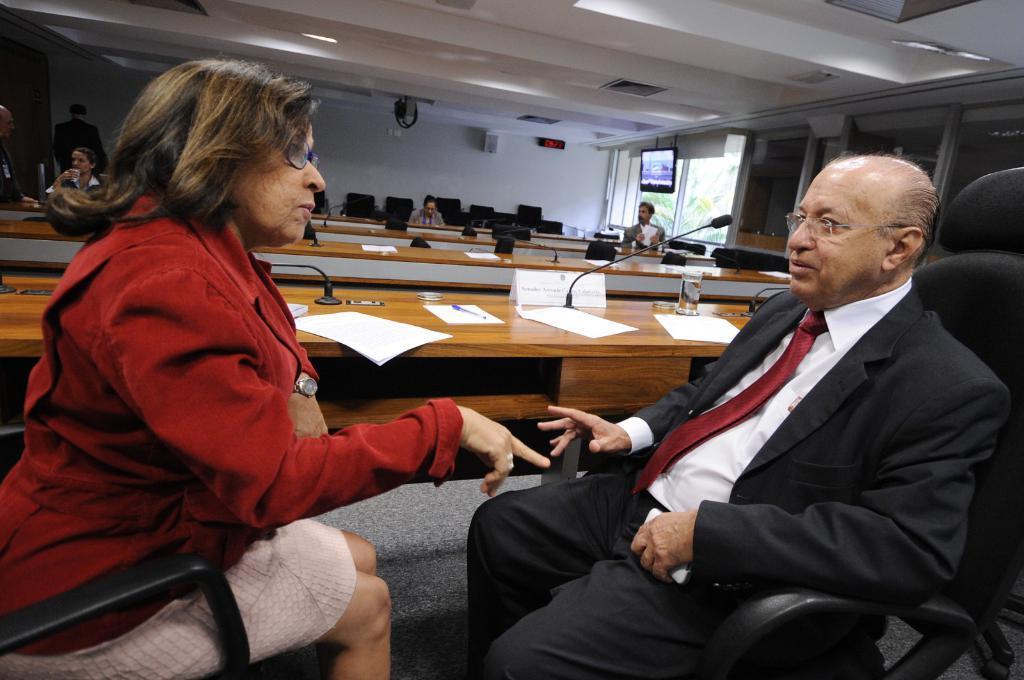Could you give a brief overview of what you see in this image? This image consists of two persons in the front, the woman is wearing a red jacket. The man is wearing a black suit. At the bottom, there is a floor mat. In the middle, there are tables. In the background, there are few persons. At the top, there is a roof. On the right, we can see a screen. 